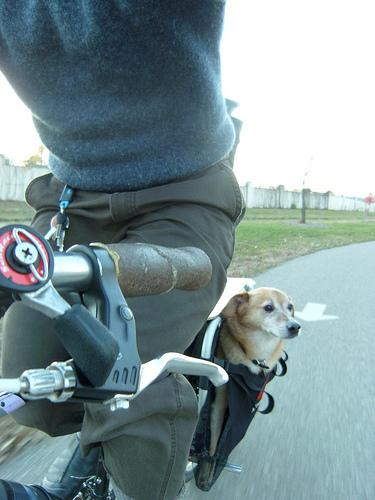Identify the color and style of the dog's leash or collar. The dog's collar is not clearly visible, but it appears to be dark in color. Express the emotion of the dog in the image and its specific location. The dog is enjoying the ride as it sits inside a bag on the bike. Can you provide information about the person's outfit and any accessories? The person is wearing a dark blue sweater, black pants, and has keys attached to their belt loop. Tell me about the animal in the image and its color. A brown dog with floppy ears is in a black bag. Explain the position and description of the arrow on the road. There is a white arrow painted on the street, pointing upwards. In the image, what type of hardware is red and has a background? It is an unidentified object with a red background. What is the main object depicted within the image that involves transportation? A motorcycle being ridden by a person. What type of vegetation is visible in the image? Green grass is seen next to the street. What features or details can you describe about the bike's handle? The handle is grey, worn out, with a grip and a Phillips screw on it. Mention the fence's characteristics and location in the image. A long, white wooden fence is next to the grass. 